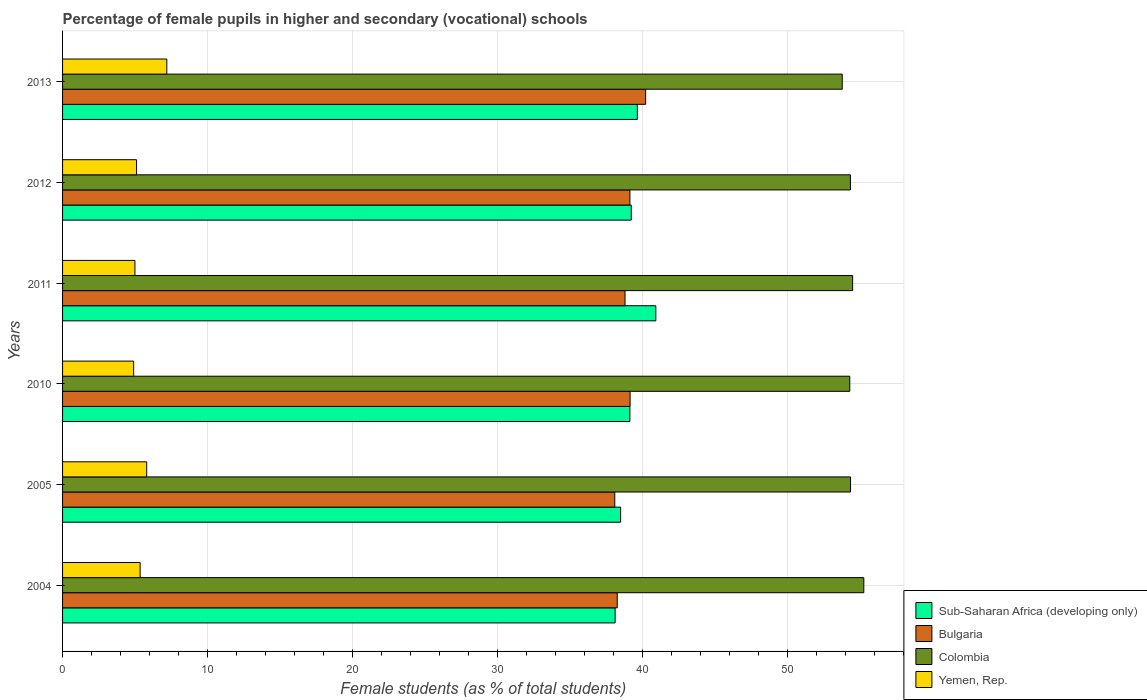Are the number of bars per tick equal to the number of legend labels?
Offer a terse response. Yes. How many bars are there on the 4th tick from the top?
Ensure brevity in your answer.  4. What is the percentage of female pupils in higher and secondary schools in Colombia in 2010?
Provide a short and direct response. 54.28. Across all years, what is the maximum percentage of female pupils in higher and secondary schools in Colombia?
Your answer should be compact. 55.25. Across all years, what is the minimum percentage of female pupils in higher and secondary schools in Yemen, Rep.?
Ensure brevity in your answer.  4.9. What is the total percentage of female pupils in higher and secondary schools in Yemen, Rep. in the graph?
Your response must be concise. 33.33. What is the difference between the percentage of female pupils in higher and secondary schools in Sub-Saharan Africa (developing only) in 2004 and that in 2005?
Give a very brief answer. -0.38. What is the difference between the percentage of female pupils in higher and secondary schools in Bulgaria in 2010 and the percentage of female pupils in higher and secondary schools in Sub-Saharan Africa (developing only) in 2012?
Provide a succinct answer. -0.08. What is the average percentage of female pupils in higher and secondary schools in Yemen, Rep. per year?
Make the answer very short. 5.56. In the year 2004, what is the difference between the percentage of female pupils in higher and secondary schools in Sub-Saharan Africa (developing only) and percentage of female pupils in higher and secondary schools in Colombia?
Give a very brief answer. -17.15. In how many years, is the percentage of female pupils in higher and secondary schools in Bulgaria greater than 40 %?
Ensure brevity in your answer.  1. What is the ratio of the percentage of female pupils in higher and secondary schools in Colombia in 2004 to that in 2012?
Your response must be concise. 1.02. Is the difference between the percentage of female pupils in higher and secondary schools in Sub-Saharan Africa (developing only) in 2005 and 2012 greater than the difference between the percentage of female pupils in higher and secondary schools in Colombia in 2005 and 2012?
Your answer should be very brief. No. What is the difference between the highest and the second highest percentage of female pupils in higher and secondary schools in Sub-Saharan Africa (developing only)?
Your answer should be compact. 1.27. What is the difference between the highest and the lowest percentage of female pupils in higher and secondary schools in Colombia?
Your response must be concise. 1.49. What does the 4th bar from the bottom in 2011 represents?
Give a very brief answer. Yemen, Rep. How many bars are there?
Provide a succinct answer. 24. What is the difference between two consecutive major ticks on the X-axis?
Keep it short and to the point. 10. Are the values on the major ticks of X-axis written in scientific E-notation?
Your answer should be compact. No. Does the graph contain grids?
Your answer should be compact. Yes. How many legend labels are there?
Give a very brief answer. 4. What is the title of the graph?
Ensure brevity in your answer.  Percentage of female pupils in higher and secondary (vocational) schools. Does "Montenegro" appear as one of the legend labels in the graph?
Keep it short and to the point. No. What is the label or title of the X-axis?
Your response must be concise. Female students (as % of total students). What is the Female students (as % of total students) of Sub-Saharan Africa (developing only) in 2004?
Provide a succinct answer. 38.1. What is the Female students (as % of total students) in Bulgaria in 2004?
Your response must be concise. 38.25. What is the Female students (as % of total students) in Colombia in 2004?
Offer a terse response. 55.25. What is the Female students (as % of total students) in Yemen, Rep. in 2004?
Keep it short and to the point. 5.35. What is the Female students (as % of total students) of Sub-Saharan Africa (developing only) in 2005?
Give a very brief answer. 38.48. What is the Female students (as % of total students) of Bulgaria in 2005?
Give a very brief answer. 38.08. What is the Female students (as % of total students) of Colombia in 2005?
Your answer should be very brief. 54.33. What is the Female students (as % of total students) of Yemen, Rep. in 2005?
Provide a succinct answer. 5.8. What is the Female students (as % of total students) of Sub-Saharan Africa (developing only) in 2010?
Your response must be concise. 39.12. What is the Female students (as % of total students) in Bulgaria in 2010?
Offer a terse response. 39.13. What is the Female students (as % of total students) in Colombia in 2010?
Your answer should be compact. 54.28. What is the Female students (as % of total students) of Yemen, Rep. in 2010?
Ensure brevity in your answer.  4.9. What is the Female students (as % of total students) of Sub-Saharan Africa (developing only) in 2011?
Give a very brief answer. 40.91. What is the Female students (as % of total students) in Bulgaria in 2011?
Make the answer very short. 38.78. What is the Female students (as % of total students) of Colombia in 2011?
Offer a very short reply. 54.48. What is the Female students (as % of total students) in Yemen, Rep. in 2011?
Offer a terse response. 4.99. What is the Female students (as % of total students) in Sub-Saharan Africa (developing only) in 2012?
Ensure brevity in your answer.  39.21. What is the Female students (as % of total students) in Bulgaria in 2012?
Make the answer very short. 39.12. What is the Female students (as % of total students) in Colombia in 2012?
Your answer should be compact. 54.33. What is the Female students (as % of total students) in Yemen, Rep. in 2012?
Provide a short and direct response. 5.1. What is the Female students (as % of total students) of Sub-Saharan Africa (developing only) in 2013?
Provide a short and direct response. 39.63. What is the Female students (as % of total students) of Bulgaria in 2013?
Provide a succinct answer. 40.21. What is the Female students (as % of total students) of Colombia in 2013?
Give a very brief answer. 53.76. What is the Female students (as % of total students) of Yemen, Rep. in 2013?
Your response must be concise. 7.19. Across all years, what is the maximum Female students (as % of total students) in Sub-Saharan Africa (developing only)?
Offer a very short reply. 40.91. Across all years, what is the maximum Female students (as % of total students) in Bulgaria?
Give a very brief answer. 40.21. Across all years, what is the maximum Female students (as % of total students) in Colombia?
Your response must be concise. 55.25. Across all years, what is the maximum Female students (as % of total students) in Yemen, Rep.?
Give a very brief answer. 7.19. Across all years, what is the minimum Female students (as % of total students) of Sub-Saharan Africa (developing only)?
Your answer should be very brief. 38.1. Across all years, what is the minimum Female students (as % of total students) of Bulgaria?
Make the answer very short. 38.08. Across all years, what is the minimum Female students (as % of total students) in Colombia?
Offer a very short reply. 53.76. Across all years, what is the minimum Female students (as % of total students) of Yemen, Rep.?
Ensure brevity in your answer.  4.9. What is the total Female students (as % of total students) in Sub-Saharan Africa (developing only) in the graph?
Keep it short and to the point. 235.45. What is the total Female students (as % of total students) in Bulgaria in the graph?
Keep it short and to the point. 233.56. What is the total Female students (as % of total students) in Colombia in the graph?
Give a very brief answer. 326.43. What is the total Female students (as % of total students) of Yemen, Rep. in the graph?
Offer a very short reply. 33.33. What is the difference between the Female students (as % of total students) in Sub-Saharan Africa (developing only) in 2004 and that in 2005?
Your response must be concise. -0.38. What is the difference between the Female students (as % of total students) of Bulgaria in 2004 and that in 2005?
Provide a short and direct response. 0.17. What is the difference between the Female students (as % of total students) in Colombia in 2004 and that in 2005?
Your answer should be compact. 0.92. What is the difference between the Female students (as % of total students) of Yemen, Rep. in 2004 and that in 2005?
Provide a short and direct response. -0.45. What is the difference between the Female students (as % of total students) in Sub-Saharan Africa (developing only) in 2004 and that in 2010?
Keep it short and to the point. -1.02. What is the difference between the Female students (as % of total students) in Bulgaria in 2004 and that in 2010?
Your response must be concise. -0.89. What is the difference between the Female students (as % of total students) of Colombia in 2004 and that in 2010?
Give a very brief answer. 0.97. What is the difference between the Female students (as % of total students) of Yemen, Rep. in 2004 and that in 2010?
Your response must be concise. 0.45. What is the difference between the Female students (as % of total students) of Sub-Saharan Africa (developing only) in 2004 and that in 2011?
Make the answer very short. -2.81. What is the difference between the Female students (as % of total students) in Bulgaria in 2004 and that in 2011?
Your answer should be compact. -0.54. What is the difference between the Female students (as % of total students) of Colombia in 2004 and that in 2011?
Provide a succinct answer. 0.77. What is the difference between the Female students (as % of total students) of Yemen, Rep. in 2004 and that in 2011?
Your answer should be compact. 0.36. What is the difference between the Female students (as % of total students) in Sub-Saharan Africa (developing only) in 2004 and that in 2012?
Offer a very short reply. -1.11. What is the difference between the Female students (as % of total students) in Bulgaria in 2004 and that in 2012?
Provide a short and direct response. -0.87. What is the difference between the Female students (as % of total students) of Colombia in 2004 and that in 2012?
Your response must be concise. 0.92. What is the difference between the Female students (as % of total students) in Yemen, Rep. in 2004 and that in 2012?
Make the answer very short. 0.25. What is the difference between the Female students (as % of total students) of Sub-Saharan Africa (developing only) in 2004 and that in 2013?
Offer a very short reply. -1.53. What is the difference between the Female students (as % of total students) in Bulgaria in 2004 and that in 2013?
Your response must be concise. -1.96. What is the difference between the Female students (as % of total students) in Colombia in 2004 and that in 2013?
Your answer should be compact. 1.49. What is the difference between the Female students (as % of total students) in Yemen, Rep. in 2004 and that in 2013?
Give a very brief answer. -1.84. What is the difference between the Female students (as % of total students) of Sub-Saharan Africa (developing only) in 2005 and that in 2010?
Keep it short and to the point. -0.64. What is the difference between the Female students (as % of total students) in Bulgaria in 2005 and that in 2010?
Offer a very short reply. -1.06. What is the difference between the Female students (as % of total students) in Colombia in 2005 and that in 2010?
Your answer should be compact. 0.05. What is the difference between the Female students (as % of total students) of Yemen, Rep. in 2005 and that in 2010?
Offer a very short reply. 0.9. What is the difference between the Female students (as % of total students) in Sub-Saharan Africa (developing only) in 2005 and that in 2011?
Keep it short and to the point. -2.43. What is the difference between the Female students (as % of total students) in Bulgaria in 2005 and that in 2011?
Your answer should be compact. -0.7. What is the difference between the Female students (as % of total students) of Colombia in 2005 and that in 2011?
Provide a short and direct response. -0.15. What is the difference between the Female students (as % of total students) of Yemen, Rep. in 2005 and that in 2011?
Provide a short and direct response. 0.81. What is the difference between the Female students (as % of total students) of Sub-Saharan Africa (developing only) in 2005 and that in 2012?
Keep it short and to the point. -0.73. What is the difference between the Female students (as % of total students) in Bulgaria in 2005 and that in 2012?
Provide a succinct answer. -1.04. What is the difference between the Female students (as % of total students) of Colombia in 2005 and that in 2012?
Offer a terse response. 0.01. What is the difference between the Female students (as % of total students) of Yemen, Rep. in 2005 and that in 2012?
Your response must be concise. 0.7. What is the difference between the Female students (as % of total students) of Sub-Saharan Africa (developing only) in 2005 and that in 2013?
Give a very brief answer. -1.15. What is the difference between the Female students (as % of total students) of Bulgaria in 2005 and that in 2013?
Your answer should be very brief. -2.13. What is the difference between the Female students (as % of total students) of Colombia in 2005 and that in 2013?
Make the answer very short. 0.57. What is the difference between the Female students (as % of total students) of Yemen, Rep. in 2005 and that in 2013?
Your answer should be compact. -1.39. What is the difference between the Female students (as % of total students) in Sub-Saharan Africa (developing only) in 2010 and that in 2011?
Your response must be concise. -1.79. What is the difference between the Female students (as % of total students) in Bulgaria in 2010 and that in 2011?
Your answer should be very brief. 0.35. What is the difference between the Female students (as % of total students) of Colombia in 2010 and that in 2011?
Make the answer very short. -0.2. What is the difference between the Female students (as % of total students) of Yemen, Rep. in 2010 and that in 2011?
Provide a short and direct response. -0.09. What is the difference between the Female students (as % of total students) of Sub-Saharan Africa (developing only) in 2010 and that in 2012?
Provide a succinct answer. -0.1. What is the difference between the Female students (as % of total students) of Bulgaria in 2010 and that in 2012?
Make the answer very short. 0.01. What is the difference between the Female students (as % of total students) in Colombia in 2010 and that in 2012?
Offer a terse response. -0.04. What is the difference between the Female students (as % of total students) of Yemen, Rep. in 2010 and that in 2012?
Provide a short and direct response. -0.2. What is the difference between the Female students (as % of total students) of Sub-Saharan Africa (developing only) in 2010 and that in 2013?
Your response must be concise. -0.52. What is the difference between the Female students (as % of total students) of Bulgaria in 2010 and that in 2013?
Provide a succinct answer. -1.07. What is the difference between the Female students (as % of total students) of Colombia in 2010 and that in 2013?
Your answer should be compact. 0.52. What is the difference between the Female students (as % of total students) in Yemen, Rep. in 2010 and that in 2013?
Your response must be concise. -2.29. What is the difference between the Female students (as % of total students) in Sub-Saharan Africa (developing only) in 2011 and that in 2012?
Offer a very short reply. 1.69. What is the difference between the Female students (as % of total students) in Bulgaria in 2011 and that in 2012?
Provide a short and direct response. -0.34. What is the difference between the Female students (as % of total students) in Colombia in 2011 and that in 2012?
Offer a very short reply. 0.15. What is the difference between the Female students (as % of total students) in Yemen, Rep. in 2011 and that in 2012?
Make the answer very short. -0.11. What is the difference between the Female students (as % of total students) in Sub-Saharan Africa (developing only) in 2011 and that in 2013?
Your answer should be very brief. 1.27. What is the difference between the Female students (as % of total students) of Bulgaria in 2011 and that in 2013?
Your answer should be compact. -1.42. What is the difference between the Female students (as % of total students) of Colombia in 2011 and that in 2013?
Offer a terse response. 0.72. What is the difference between the Female students (as % of total students) in Yemen, Rep. in 2011 and that in 2013?
Provide a succinct answer. -2.2. What is the difference between the Female students (as % of total students) of Sub-Saharan Africa (developing only) in 2012 and that in 2013?
Ensure brevity in your answer.  -0.42. What is the difference between the Female students (as % of total students) in Bulgaria in 2012 and that in 2013?
Your response must be concise. -1.09. What is the difference between the Female students (as % of total students) in Colombia in 2012 and that in 2013?
Provide a short and direct response. 0.56. What is the difference between the Female students (as % of total students) in Yemen, Rep. in 2012 and that in 2013?
Make the answer very short. -2.09. What is the difference between the Female students (as % of total students) in Sub-Saharan Africa (developing only) in 2004 and the Female students (as % of total students) in Bulgaria in 2005?
Your response must be concise. 0.02. What is the difference between the Female students (as % of total students) of Sub-Saharan Africa (developing only) in 2004 and the Female students (as % of total students) of Colombia in 2005?
Your response must be concise. -16.23. What is the difference between the Female students (as % of total students) of Sub-Saharan Africa (developing only) in 2004 and the Female students (as % of total students) of Yemen, Rep. in 2005?
Ensure brevity in your answer.  32.3. What is the difference between the Female students (as % of total students) in Bulgaria in 2004 and the Female students (as % of total students) in Colombia in 2005?
Your response must be concise. -16.09. What is the difference between the Female students (as % of total students) in Bulgaria in 2004 and the Female students (as % of total students) in Yemen, Rep. in 2005?
Your answer should be very brief. 32.44. What is the difference between the Female students (as % of total students) of Colombia in 2004 and the Female students (as % of total students) of Yemen, Rep. in 2005?
Your answer should be compact. 49.45. What is the difference between the Female students (as % of total students) in Sub-Saharan Africa (developing only) in 2004 and the Female students (as % of total students) in Bulgaria in 2010?
Keep it short and to the point. -1.03. What is the difference between the Female students (as % of total students) in Sub-Saharan Africa (developing only) in 2004 and the Female students (as % of total students) in Colombia in 2010?
Your response must be concise. -16.18. What is the difference between the Female students (as % of total students) in Sub-Saharan Africa (developing only) in 2004 and the Female students (as % of total students) in Yemen, Rep. in 2010?
Ensure brevity in your answer.  33.2. What is the difference between the Female students (as % of total students) of Bulgaria in 2004 and the Female students (as % of total students) of Colombia in 2010?
Your response must be concise. -16.03. What is the difference between the Female students (as % of total students) of Bulgaria in 2004 and the Female students (as % of total students) of Yemen, Rep. in 2010?
Your response must be concise. 33.34. What is the difference between the Female students (as % of total students) in Colombia in 2004 and the Female students (as % of total students) in Yemen, Rep. in 2010?
Provide a succinct answer. 50.35. What is the difference between the Female students (as % of total students) of Sub-Saharan Africa (developing only) in 2004 and the Female students (as % of total students) of Bulgaria in 2011?
Your response must be concise. -0.68. What is the difference between the Female students (as % of total students) in Sub-Saharan Africa (developing only) in 2004 and the Female students (as % of total students) in Colombia in 2011?
Provide a succinct answer. -16.38. What is the difference between the Female students (as % of total students) in Sub-Saharan Africa (developing only) in 2004 and the Female students (as % of total students) in Yemen, Rep. in 2011?
Give a very brief answer. 33.11. What is the difference between the Female students (as % of total students) in Bulgaria in 2004 and the Female students (as % of total students) in Colombia in 2011?
Your answer should be compact. -16.23. What is the difference between the Female students (as % of total students) of Bulgaria in 2004 and the Female students (as % of total students) of Yemen, Rep. in 2011?
Your answer should be compact. 33.26. What is the difference between the Female students (as % of total students) in Colombia in 2004 and the Female students (as % of total students) in Yemen, Rep. in 2011?
Ensure brevity in your answer.  50.26. What is the difference between the Female students (as % of total students) of Sub-Saharan Africa (developing only) in 2004 and the Female students (as % of total students) of Bulgaria in 2012?
Provide a succinct answer. -1.02. What is the difference between the Female students (as % of total students) in Sub-Saharan Africa (developing only) in 2004 and the Female students (as % of total students) in Colombia in 2012?
Offer a terse response. -16.22. What is the difference between the Female students (as % of total students) of Sub-Saharan Africa (developing only) in 2004 and the Female students (as % of total students) of Yemen, Rep. in 2012?
Provide a short and direct response. 33. What is the difference between the Female students (as % of total students) of Bulgaria in 2004 and the Female students (as % of total students) of Colombia in 2012?
Ensure brevity in your answer.  -16.08. What is the difference between the Female students (as % of total students) in Bulgaria in 2004 and the Female students (as % of total students) in Yemen, Rep. in 2012?
Give a very brief answer. 33.14. What is the difference between the Female students (as % of total students) in Colombia in 2004 and the Female students (as % of total students) in Yemen, Rep. in 2012?
Offer a very short reply. 50.15. What is the difference between the Female students (as % of total students) of Sub-Saharan Africa (developing only) in 2004 and the Female students (as % of total students) of Bulgaria in 2013?
Make the answer very short. -2.11. What is the difference between the Female students (as % of total students) in Sub-Saharan Africa (developing only) in 2004 and the Female students (as % of total students) in Colombia in 2013?
Provide a succinct answer. -15.66. What is the difference between the Female students (as % of total students) of Sub-Saharan Africa (developing only) in 2004 and the Female students (as % of total students) of Yemen, Rep. in 2013?
Your response must be concise. 30.91. What is the difference between the Female students (as % of total students) of Bulgaria in 2004 and the Female students (as % of total students) of Colombia in 2013?
Offer a very short reply. -15.51. What is the difference between the Female students (as % of total students) of Bulgaria in 2004 and the Female students (as % of total students) of Yemen, Rep. in 2013?
Keep it short and to the point. 31.06. What is the difference between the Female students (as % of total students) of Colombia in 2004 and the Female students (as % of total students) of Yemen, Rep. in 2013?
Provide a short and direct response. 48.06. What is the difference between the Female students (as % of total students) in Sub-Saharan Africa (developing only) in 2005 and the Female students (as % of total students) in Bulgaria in 2010?
Your answer should be very brief. -0.65. What is the difference between the Female students (as % of total students) in Sub-Saharan Africa (developing only) in 2005 and the Female students (as % of total students) in Colombia in 2010?
Offer a very short reply. -15.8. What is the difference between the Female students (as % of total students) in Sub-Saharan Africa (developing only) in 2005 and the Female students (as % of total students) in Yemen, Rep. in 2010?
Make the answer very short. 33.58. What is the difference between the Female students (as % of total students) in Bulgaria in 2005 and the Female students (as % of total students) in Colombia in 2010?
Provide a short and direct response. -16.2. What is the difference between the Female students (as % of total students) of Bulgaria in 2005 and the Female students (as % of total students) of Yemen, Rep. in 2010?
Keep it short and to the point. 33.17. What is the difference between the Female students (as % of total students) in Colombia in 2005 and the Female students (as % of total students) in Yemen, Rep. in 2010?
Ensure brevity in your answer.  49.43. What is the difference between the Female students (as % of total students) of Sub-Saharan Africa (developing only) in 2005 and the Female students (as % of total students) of Bulgaria in 2011?
Give a very brief answer. -0.3. What is the difference between the Female students (as % of total students) in Sub-Saharan Africa (developing only) in 2005 and the Female students (as % of total students) in Colombia in 2011?
Give a very brief answer. -16. What is the difference between the Female students (as % of total students) in Sub-Saharan Africa (developing only) in 2005 and the Female students (as % of total students) in Yemen, Rep. in 2011?
Your answer should be compact. 33.49. What is the difference between the Female students (as % of total students) of Bulgaria in 2005 and the Female students (as % of total students) of Colombia in 2011?
Provide a short and direct response. -16.4. What is the difference between the Female students (as % of total students) of Bulgaria in 2005 and the Female students (as % of total students) of Yemen, Rep. in 2011?
Make the answer very short. 33.09. What is the difference between the Female students (as % of total students) of Colombia in 2005 and the Female students (as % of total students) of Yemen, Rep. in 2011?
Your answer should be compact. 49.34. What is the difference between the Female students (as % of total students) of Sub-Saharan Africa (developing only) in 2005 and the Female students (as % of total students) of Bulgaria in 2012?
Ensure brevity in your answer.  -0.64. What is the difference between the Female students (as % of total students) of Sub-Saharan Africa (developing only) in 2005 and the Female students (as % of total students) of Colombia in 2012?
Provide a short and direct response. -15.85. What is the difference between the Female students (as % of total students) of Sub-Saharan Africa (developing only) in 2005 and the Female students (as % of total students) of Yemen, Rep. in 2012?
Give a very brief answer. 33.38. What is the difference between the Female students (as % of total students) in Bulgaria in 2005 and the Female students (as % of total students) in Colombia in 2012?
Your answer should be very brief. -16.25. What is the difference between the Female students (as % of total students) in Bulgaria in 2005 and the Female students (as % of total students) in Yemen, Rep. in 2012?
Your response must be concise. 32.97. What is the difference between the Female students (as % of total students) in Colombia in 2005 and the Female students (as % of total students) in Yemen, Rep. in 2012?
Your response must be concise. 49.23. What is the difference between the Female students (as % of total students) in Sub-Saharan Africa (developing only) in 2005 and the Female students (as % of total students) in Bulgaria in 2013?
Offer a terse response. -1.73. What is the difference between the Female students (as % of total students) in Sub-Saharan Africa (developing only) in 2005 and the Female students (as % of total students) in Colombia in 2013?
Your answer should be very brief. -15.28. What is the difference between the Female students (as % of total students) in Sub-Saharan Africa (developing only) in 2005 and the Female students (as % of total students) in Yemen, Rep. in 2013?
Give a very brief answer. 31.29. What is the difference between the Female students (as % of total students) of Bulgaria in 2005 and the Female students (as % of total students) of Colombia in 2013?
Make the answer very short. -15.68. What is the difference between the Female students (as % of total students) of Bulgaria in 2005 and the Female students (as % of total students) of Yemen, Rep. in 2013?
Provide a short and direct response. 30.89. What is the difference between the Female students (as % of total students) in Colombia in 2005 and the Female students (as % of total students) in Yemen, Rep. in 2013?
Your answer should be very brief. 47.14. What is the difference between the Female students (as % of total students) in Sub-Saharan Africa (developing only) in 2010 and the Female students (as % of total students) in Bulgaria in 2011?
Offer a terse response. 0.34. What is the difference between the Female students (as % of total students) of Sub-Saharan Africa (developing only) in 2010 and the Female students (as % of total students) of Colombia in 2011?
Give a very brief answer. -15.36. What is the difference between the Female students (as % of total students) of Sub-Saharan Africa (developing only) in 2010 and the Female students (as % of total students) of Yemen, Rep. in 2011?
Ensure brevity in your answer.  34.13. What is the difference between the Female students (as % of total students) in Bulgaria in 2010 and the Female students (as % of total students) in Colombia in 2011?
Your answer should be very brief. -15.34. What is the difference between the Female students (as % of total students) in Bulgaria in 2010 and the Female students (as % of total students) in Yemen, Rep. in 2011?
Your answer should be compact. 34.14. What is the difference between the Female students (as % of total students) in Colombia in 2010 and the Female students (as % of total students) in Yemen, Rep. in 2011?
Your response must be concise. 49.29. What is the difference between the Female students (as % of total students) of Sub-Saharan Africa (developing only) in 2010 and the Female students (as % of total students) of Bulgaria in 2012?
Offer a very short reply. -0. What is the difference between the Female students (as % of total students) of Sub-Saharan Africa (developing only) in 2010 and the Female students (as % of total students) of Colombia in 2012?
Your answer should be very brief. -15.21. What is the difference between the Female students (as % of total students) of Sub-Saharan Africa (developing only) in 2010 and the Female students (as % of total students) of Yemen, Rep. in 2012?
Your answer should be very brief. 34.01. What is the difference between the Female students (as % of total students) of Bulgaria in 2010 and the Female students (as % of total students) of Colombia in 2012?
Your answer should be compact. -15.19. What is the difference between the Female students (as % of total students) in Bulgaria in 2010 and the Female students (as % of total students) in Yemen, Rep. in 2012?
Ensure brevity in your answer.  34.03. What is the difference between the Female students (as % of total students) in Colombia in 2010 and the Female students (as % of total students) in Yemen, Rep. in 2012?
Your answer should be compact. 49.18. What is the difference between the Female students (as % of total students) in Sub-Saharan Africa (developing only) in 2010 and the Female students (as % of total students) in Bulgaria in 2013?
Offer a terse response. -1.09. What is the difference between the Female students (as % of total students) in Sub-Saharan Africa (developing only) in 2010 and the Female students (as % of total students) in Colombia in 2013?
Offer a very short reply. -14.64. What is the difference between the Female students (as % of total students) in Sub-Saharan Africa (developing only) in 2010 and the Female students (as % of total students) in Yemen, Rep. in 2013?
Provide a short and direct response. 31.93. What is the difference between the Female students (as % of total students) in Bulgaria in 2010 and the Female students (as % of total students) in Colombia in 2013?
Make the answer very short. -14.63. What is the difference between the Female students (as % of total students) of Bulgaria in 2010 and the Female students (as % of total students) of Yemen, Rep. in 2013?
Provide a short and direct response. 31.95. What is the difference between the Female students (as % of total students) of Colombia in 2010 and the Female students (as % of total students) of Yemen, Rep. in 2013?
Offer a very short reply. 47.09. What is the difference between the Female students (as % of total students) of Sub-Saharan Africa (developing only) in 2011 and the Female students (as % of total students) of Bulgaria in 2012?
Keep it short and to the point. 1.79. What is the difference between the Female students (as % of total students) in Sub-Saharan Africa (developing only) in 2011 and the Female students (as % of total students) in Colombia in 2012?
Keep it short and to the point. -13.42. What is the difference between the Female students (as % of total students) of Sub-Saharan Africa (developing only) in 2011 and the Female students (as % of total students) of Yemen, Rep. in 2012?
Offer a very short reply. 35.81. What is the difference between the Female students (as % of total students) in Bulgaria in 2011 and the Female students (as % of total students) in Colombia in 2012?
Provide a succinct answer. -15.54. What is the difference between the Female students (as % of total students) of Bulgaria in 2011 and the Female students (as % of total students) of Yemen, Rep. in 2012?
Your answer should be compact. 33.68. What is the difference between the Female students (as % of total students) in Colombia in 2011 and the Female students (as % of total students) in Yemen, Rep. in 2012?
Your response must be concise. 49.38. What is the difference between the Female students (as % of total students) in Sub-Saharan Africa (developing only) in 2011 and the Female students (as % of total students) in Bulgaria in 2013?
Keep it short and to the point. 0.7. What is the difference between the Female students (as % of total students) of Sub-Saharan Africa (developing only) in 2011 and the Female students (as % of total students) of Colombia in 2013?
Offer a very short reply. -12.85. What is the difference between the Female students (as % of total students) of Sub-Saharan Africa (developing only) in 2011 and the Female students (as % of total students) of Yemen, Rep. in 2013?
Your response must be concise. 33.72. What is the difference between the Female students (as % of total students) of Bulgaria in 2011 and the Female students (as % of total students) of Colombia in 2013?
Provide a short and direct response. -14.98. What is the difference between the Female students (as % of total students) in Bulgaria in 2011 and the Female students (as % of total students) in Yemen, Rep. in 2013?
Make the answer very short. 31.59. What is the difference between the Female students (as % of total students) in Colombia in 2011 and the Female students (as % of total students) in Yemen, Rep. in 2013?
Offer a terse response. 47.29. What is the difference between the Female students (as % of total students) of Sub-Saharan Africa (developing only) in 2012 and the Female students (as % of total students) of Bulgaria in 2013?
Make the answer very short. -0.99. What is the difference between the Female students (as % of total students) in Sub-Saharan Africa (developing only) in 2012 and the Female students (as % of total students) in Colombia in 2013?
Give a very brief answer. -14.55. What is the difference between the Female students (as % of total students) of Sub-Saharan Africa (developing only) in 2012 and the Female students (as % of total students) of Yemen, Rep. in 2013?
Make the answer very short. 32.03. What is the difference between the Female students (as % of total students) of Bulgaria in 2012 and the Female students (as % of total students) of Colombia in 2013?
Your response must be concise. -14.64. What is the difference between the Female students (as % of total students) in Bulgaria in 2012 and the Female students (as % of total students) in Yemen, Rep. in 2013?
Give a very brief answer. 31.93. What is the difference between the Female students (as % of total students) in Colombia in 2012 and the Female students (as % of total students) in Yemen, Rep. in 2013?
Your response must be concise. 47.14. What is the average Female students (as % of total students) in Sub-Saharan Africa (developing only) per year?
Offer a terse response. 39.24. What is the average Female students (as % of total students) of Bulgaria per year?
Your answer should be very brief. 38.93. What is the average Female students (as % of total students) of Colombia per year?
Your answer should be compact. 54.4. What is the average Female students (as % of total students) in Yemen, Rep. per year?
Offer a very short reply. 5.56. In the year 2004, what is the difference between the Female students (as % of total students) of Sub-Saharan Africa (developing only) and Female students (as % of total students) of Bulgaria?
Keep it short and to the point. -0.15. In the year 2004, what is the difference between the Female students (as % of total students) in Sub-Saharan Africa (developing only) and Female students (as % of total students) in Colombia?
Offer a terse response. -17.15. In the year 2004, what is the difference between the Female students (as % of total students) in Sub-Saharan Africa (developing only) and Female students (as % of total students) in Yemen, Rep.?
Keep it short and to the point. 32.75. In the year 2004, what is the difference between the Female students (as % of total students) in Bulgaria and Female students (as % of total students) in Colombia?
Your answer should be very brief. -17. In the year 2004, what is the difference between the Female students (as % of total students) in Bulgaria and Female students (as % of total students) in Yemen, Rep.?
Your response must be concise. 32.9. In the year 2004, what is the difference between the Female students (as % of total students) in Colombia and Female students (as % of total students) in Yemen, Rep.?
Provide a short and direct response. 49.9. In the year 2005, what is the difference between the Female students (as % of total students) of Sub-Saharan Africa (developing only) and Female students (as % of total students) of Bulgaria?
Give a very brief answer. 0.4. In the year 2005, what is the difference between the Female students (as % of total students) in Sub-Saharan Africa (developing only) and Female students (as % of total students) in Colombia?
Your response must be concise. -15.85. In the year 2005, what is the difference between the Female students (as % of total students) of Sub-Saharan Africa (developing only) and Female students (as % of total students) of Yemen, Rep.?
Give a very brief answer. 32.68. In the year 2005, what is the difference between the Female students (as % of total students) in Bulgaria and Female students (as % of total students) in Colombia?
Ensure brevity in your answer.  -16.26. In the year 2005, what is the difference between the Female students (as % of total students) of Bulgaria and Female students (as % of total students) of Yemen, Rep.?
Provide a short and direct response. 32.27. In the year 2005, what is the difference between the Female students (as % of total students) of Colombia and Female students (as % of total students) of Yemen, Rep.?
Your answer should be compact. 48.53. In the year 2010, what is the difference between the Female students (as % of total students) of Sub-Saharan Africa (developing only) and Female students (as % of total students) of Bulgaria?
Ensure brevity in your answer.  -0.02. In the year 2010, what is the difference between the Female students (as % of total students) of Sub-Saharan Africa (developing only) and Female students (as % of total students) of Colombia?
Provide a short and direct response. -15.16. In the year 2010, what is the difference between the Female students (as % of total students) of Sub-Saharan Africa (developing only) and Female students (as % of total students) of Yemen, Rep.?
Your answer should be very brief. 34.22. In the year 2010, what is the difference between the Female students (as % of total students) in Bulgaria and Female students (as % of total students) in Colombia?
Offer a terse response. -15.15. In the year 2010, what is the difference between the Female students (as % of total students) in Bulgaria and Female students (as % of total students) in Yemen, Rep.?
Provide a short and direct response. 34.23. In the year 2010, what is the difference between the Female students (as % of total students) of Colombia and Female students (as % of total students) of Yemen, Rep.?
Make the answer very short. 49.38. In the year 2011, what is the difference between the Female students (as % of total students) in Sub-Saharan Africa (developing only) and Female students (as % of total students) in Bulgaria?
Your answer should be very brief. 2.13. In the year 2011, what is the difference between the Female students (as % of total students) of Sub-Saharan Africa (developing only) and Female students (as % of total students) of Colombia?
Your response must be concise. -13.57. In the year 2011, what is the difference between the Female students (as % of total students) of Sub-Saharan Africa (developing only) and Female students (as % of total students) of Yemen, Rep.?
Provide a succinct answer. 35.92. In the year 2011, what is the difference between the Female students (as % of total students) of Bulgaria and Female students (as % of total students) of Colombia?
Your answer should be compact. -15.7. In the year 2011, what is the difference between the Female students (as % of total students) of Bulgaria and Female students (as % of total students) of Yemen, Rep.?
Provide a succinct answer. 33.79. In the year 2011, what is the difference between the Female students (as % of total students) in Colombia and Female students (as % of total students) in Yemen, Rep.?
Make the answer very short. 49.49. In the year 2012, what is the difference between the Female students (as % of total students) of Sub-Saharan Africa (developing only) and Female students (as % of total students) of Bulgaria?
Your answer should be very brief. 0.09. In the year 2012, what is the difference between the Female students (as % of total students) in Sub-Saharan Africa (developing only) and Female students (as % of total students) in Colombia?
Offer a very short reply. -15.11. In the year 2012, what is the difference between the Female students (as % of total students) of Sub-Saharan Africa (developing only) and Female students (as % of total students) of Yemen, Rep.?
Give a very brief answer. 34.11. In the year 2012, what is the difference between the Female students (as % of total students) in Bulgaria and Female students (as % of total students) in Colombia?
Your answer should be very brief. -15.21. In the year 2012, what is the difference between the Female students (as % of total students) of Bulgaria and Female students (as % of total students) of Yemen, Rep.?
Your response must be concise. 34.02. In the year 2012, what is the difference between the Female students (as % of total students) of Colombia and Female students (as % of total students) of Yemen, Rep.?
Keep it short and to the point. 49.22. In the year 2013, what is the difference between the Female students (as % of total students) of Sub-Saharan Africa (developing only) and Female students (as % of total students) of Bulgaria?
Your answer should be compact. -0.57. In the year 2013, what is the difference between the Female students (as % of total students) in Sub-Saharan Africa (developing only) and Female students (as % of total students) in Colombia?
Ensure brevity in your answer.  -14.13. In the year 2013, what is the difference between the Female students (as % of total students) in Sub-Saharan Africa (developing only) and Female students (as % of total students) in Yemen, Rep.?
Offer a very short reply. 32.45. In the year 2013, what is the difference between the Female students (as % of total students) in Bulgaria and Female students (as % of total students) in Colombia?
Your answer should be compact. -13.55. In the year 2013, what is the difference between the Female students (as % of total students) in Bulgaria and Female students (as % of total students) in Yemen, Rep.?
Offer a terse response. 33.02. In the year 2013, what is the difference between the Female students (as % of total students) of Colombia and Female students (as % of total students) of Yemen, Rep.?
Make the answer very short. 46.57. What is the ratio of the Female students (as % of total students) of Sub-Saharan Africa (developing only) in 2004 to that in 2005?
Your response must be concise. 0.99. What is the ratio of the Female students (as % of total students) in Colombia in 2004 to that in 2005?
Provide a short and direct response. 1.02. What is the ratio of the Female students (as % of total students) of Yemen, Rep. in 2004 to that in 2005?
Your answer should be very brief. 0.92. What is the ratio of the Female students (as % of total students) of Sub-Saharan Africa (developing only) in 2004 to that in 2010?
Your answer should be compact. 0.97. What is the ratio of the Female students (as % of total students) in Bulgaria in 2004 to that in 2010?
Keep it short and to the point. 0.98. What is the ratio of the Female students (as % of total students) in Colombia in 2004 to that in 2010?
Provide a succinct answer. 1.02. What is the ratio of the Female students (as % of total students) in Sub-Saharan Africa (developing only) in 2004 to that in 2011?
Make the answer very short. 0.93. What is the ratio of the Female students (as % of total students) in Bulgaria in 2004 to that in 2011?
Provide a short and direct response. 0.99. What is the ratio of the Female students (as % of total students) in Colombia in 2004 to that in 2011?
Your answer should be very brief. 1.01. What is the ratio of the Female students (as % of total students) of Yemen, Rep. in 2004 to that in 2011?
Your answer should be compact. 1.07. What is the ratio of the Female students (as % of total students) of Sub-Saharan Africa (developing only) in 2004 to that in 2012?
Keep it short and to the point. 0.97. What is the ratio of the Female students (as % of total students) in Bulgaria in 2004 to that in 2012?
Make the answer very short. 0.98. What is the ratio of the Female students (as % of total students) of Yemen, Rep. in 2004 to that in 2012?
Make the answer very short. 1.05. What is the ratio of the Female students (as % of total students) of Sub-Saharan Africa (developing only) in 2004 to that in 2013?
Your answer should be compact. 0.96. What is the ratio of the Female students (as % of total students) of Bulgaria in 2004 to that in 2013?
Your answer should be very brief. 0.95. What is the ratio of the Female students (as % of total students) of Colombia in 2004 to that in 2013?
Ensure brevity in your answer.  1.03. What is the ratio of the Female students (as % of total students) in Yemen, Rep. in 2004 to that in 2013?
Provide a short and direct response. 0.74. What is the ratio of the Female students (as % of total students) in Sub-Saharan Africa (developing only) in 2005 to that in 2010?
Your answer should be very brief. 0.98. What is the ratio of the Female students (as % of total students) of Colombia in 2005 to that in 2010?
Give a very brief answer. 1. What is the ratio of the Female students (as % of total students) of Yemen, Rep. in 2005 to that in 2010?
Your answer should be very brief. 1.18. What is the ratio of the Female students (as % of total students) of Sub-Saharan Africa (developing only) in 2005 to that in 2011?
Give a very brief answer. 0.94. What is the ratio of the Female students (as % of total students) in Bulgaria in 2005 to that in 2011?
Offer a terse response. 0.98. What is the ratio of the Female students (as % of total students) in Yemen, Rep. in 2005 to that in 2011?
Provide a succinct answer. 1.16. What is the ratio of the Female students (as % of total students) in Sub-Saharan Africa (developing only) in 2005 to that in 2012?
Make the answer very short. 0.98. What is the ratio of the Female students (as % of total students) in Bulgaria in 2005 to that in 2012?
Offer a terse response. 0.97. What is the ratio of the Female students (as % of total students) of Yemen, Rep. in 2005 to that in 2012?
Your response must be concise. 1.14. What is the ratio of the Female students (as % of total students) of Sub-Saharan Africa (developing only) in 2005 to that in 2013?
Offer a terse response. 0.97. What is the ratio of the Female students (as % of total students) of Bulgaria in 2005 to that in 2013?
Give a very brief answer. 0.95. What is the ratio of the Female students (as % of total students) of Colombia in 2005 to that in 2013?
Offer a terse response. 1.01. What is the ratio of the Female students (as % of total students) in Yemen, Rep. in 2005 to that in 2013?
Offer a terse response. 0.81. What is the ratio of the Female students (as % of total students) in Sub-Saharan Africa (developing only) in 2010 to that in 2011?
Offer a very short reply. 0.96. What is the ratio of the Female students (as % of total students) of Bulgaria in 2010 to that in 2011?
Provide a short and direct response. 1.01. What is the ratio of the Female students (as % of total students) in Colombia in 2010 to that in 2011?
Offer a terse response. 1. What is the ratio of the Female students (as % of total students) in Yemen, Rep. in 2010 to that in 2011?
Your answer should be very brief. 0.98. What is the ratio of the Female students (as % of total students) of Yemen, Rep. in 2010 to that in 2012?
Your answer should be very brief. 0.96. What is the ratio of the Female students (as % of total students) of Bulgaria in 2010 to that in 2013?
Provide a short and direct response. 0.97. What is the ratio of the Female students (as % of total students) of Colombia in 2010 to that in 2013?
Provide a succinct answer. 1.01. What is the ratio of the Female students (as % of total students) in Yemen, Rep. in 2010 to that in 2013?
Ensure brevity in your answer.  0.68. What is the ratio of the Female students (as % of total students) in Sub-Saharan Africa (developing only) in 2011 to that in 2012?
Give a very brief answer. 1.04. What is the ratio of the Female students (as % of total students) of Bulgaria in 2011 to that in 2012?
Provide a short and direct response. 0.99. What is the ratio of the Female students (as % of total students) of Colombia in 2011 to that in 2012?
Your answer should be very brief. 1. What is the ratio of the Female students (as % of total students) of Yemen, Rep. in 2011 to that in 2012?
Your answer should be very brief. 0.98. What is the ratio of the Female students (as % of total students) in Sub-Saharan Africa (developing only) in 2011 to that in 2013?
Provide a succinct answer. 1.03. What is the ratio of the Female students (as % of total students) of Bulgaria in 2011 to that in 2013?
Offer a terse response. 0.96. What is the ratio of the Female students (as % of total students) in Colombia in 2011 to that in 2013?
Provide a short and direct response. 1.01. What is the ratio of the Female students (as % of total students) of Yemen, Rep. in 2011 to that in 2013?
Keep it short and to the point. 0.69. What is the ratio of the Female students (as % of total students) in Bulgaria in 2012 to that in 2013?
Provide a succinct answer. 0.97. What is the ratio of the Female students (as % of total students) of Colombia in 2012 to that in 2013?
Your response must be concise. 1.01. What is the ratio of the Female students (as % of total students) of Yemen, Rep. in 2012 to that in 2013?
Provide a succinct answer. 0.71. What is the difference between the highest and the second highest Female students (as % of total students) in Sub-Saharan Africa (developing only)?
Make the answer very short. 1.27. What is the difference between the highest and the second highest Female students (as % of total students) of Bulgaria?
Make the answer very short. 1.07. What is the difference between the highest and the second highest Female students (as % of total students) of Colombia?
Ensure brevity in your answer.  0.77. What is the difference between the highest and the second highest Female students (as % of total students) in Yemen, Rep.?
Provide a succinct answer. 1.39. What is the difference between the highest and the lowest Female students (as % of total students) of Sub-Saharan Africa (developing only)?
Your response must be concise. 2.81. What is the difference between the highest and the lowest Female students (as % of total students) of Bulgaria?
Offer a terse response. 2.13. What is the difference between the highest and the lowest Female students (as % of total students) of Colombia?
Give a very brief answer. 1.49. What is the difference between the highest and the lowest Female students (as % of total students) of Yemen, Rep.?
Give a very brief answer. 2.29. 